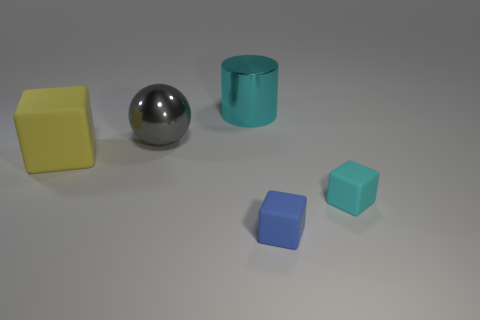Add 3 big cyan things. How many objects exist? 8 Add 1 cyan shiny cylinders. How many cyan shiny cylinders are left? 2 Add 3 tiny blocks. How many tiny blocks exist? 5 Subtract 0 yellow balls. How many objects are left? 5 Subtract all spheres. How many objects are left? 4 Subtract all blue blocks. Subtract all big brown matte objects. How many objects are left? 4 